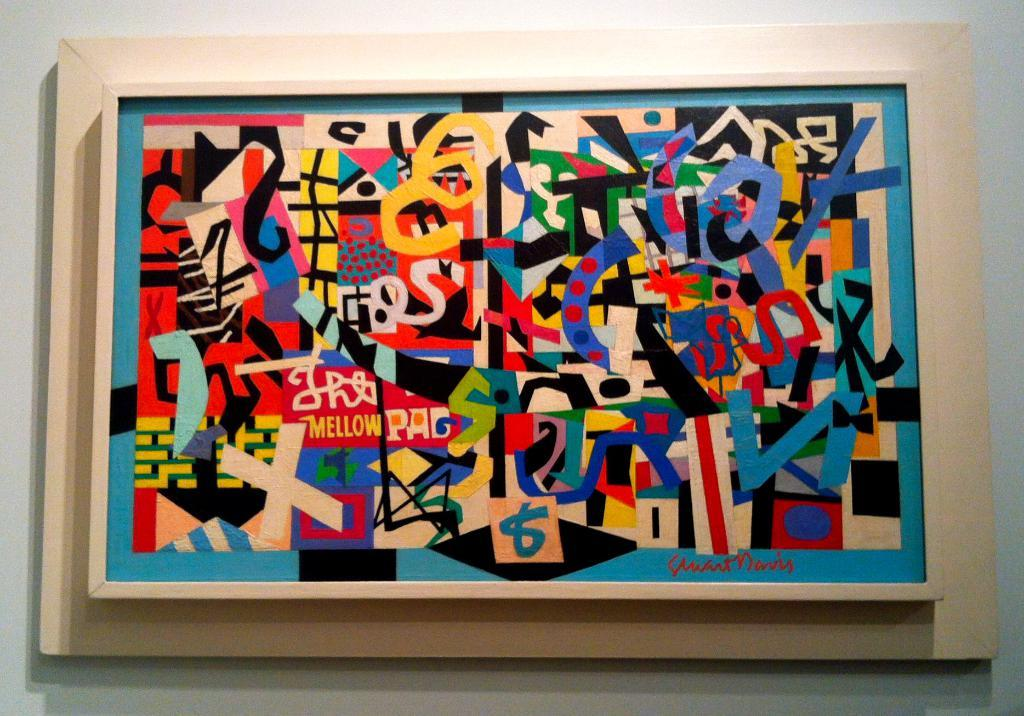<image>
Summarize the visual content of the image. A modern art paiting on a wall that has the word mellow in it. 